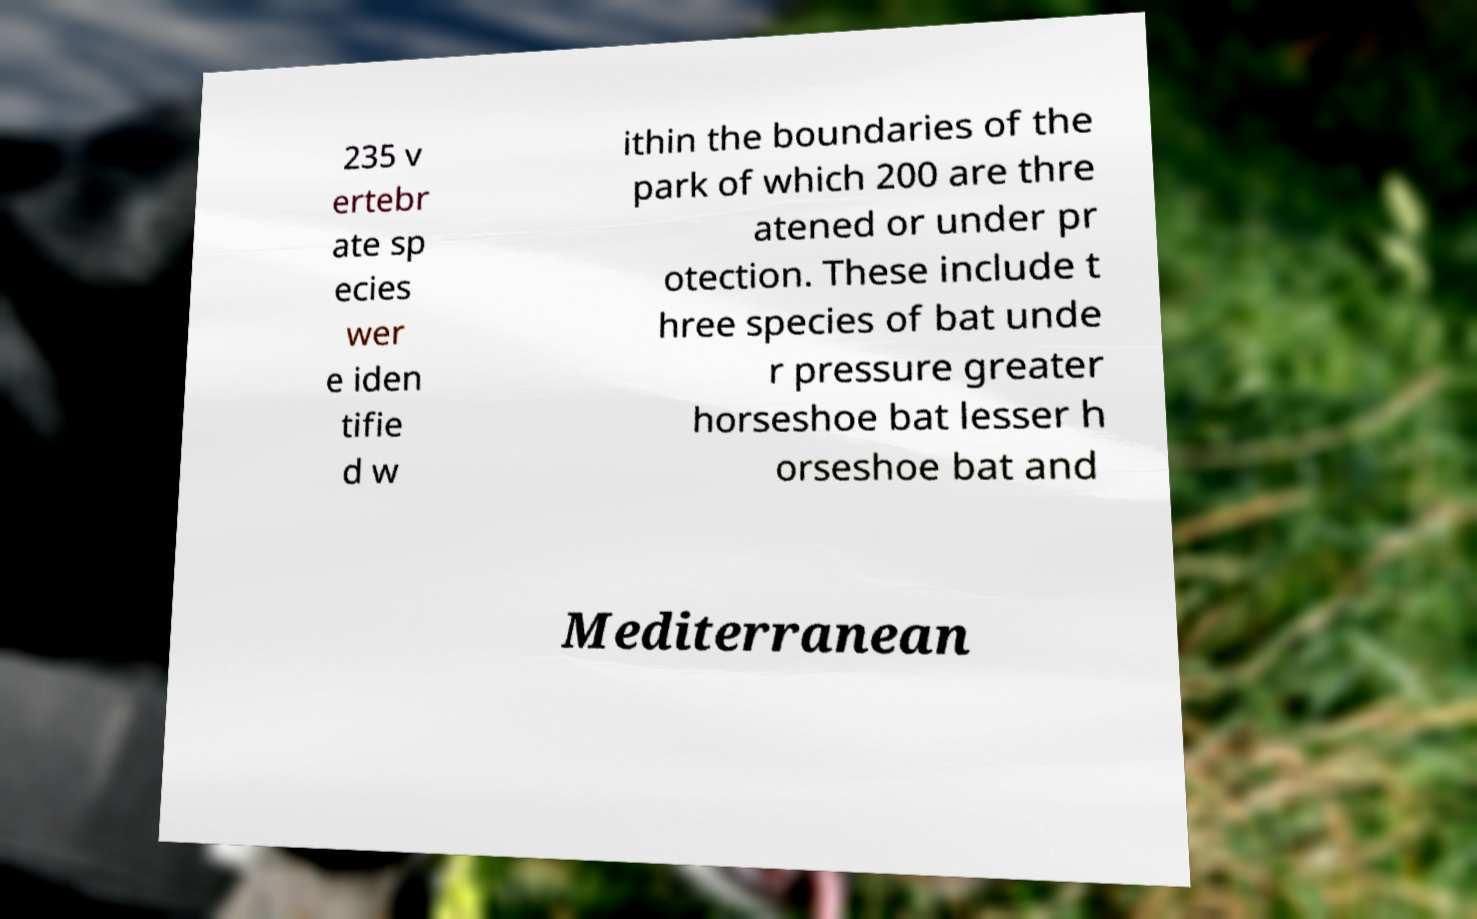Could you assist in decoding the text presented in this image and type it out clearly? 235 v ertebr ate sp ecies wer e iden tifie d w ithin the boundaries of the park of which 200 are thre atened or under pr otection. These include t hree species of bat unde r pressure greater horseshoe bat lesser h orseshoe bat and Mediterranean 